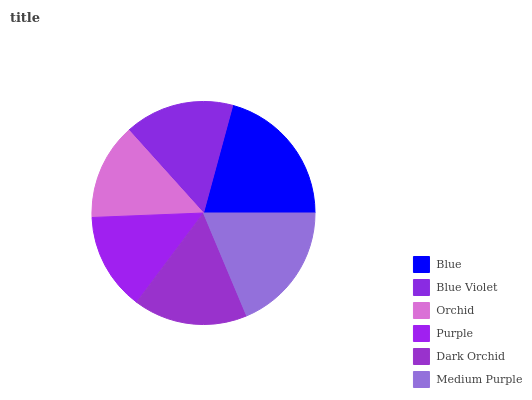Is Orchid the minimum?
Answer yes or no. Yes. Is Blue the maximum?
Answer yes or no. Yes. Is Blue Violet the minimum?
Answer yes or no. No. Is Blue Violet the maximum?
Answer yes or no. No. Is Blue greater than Blue Violet?
Answer yes or no. Yes. Is Blue Violet less than Blue?
Answer yes or no. Yes. Is Blue Violet greater than Blue?
Answer yes or no. No. Is Blue less than Blue Violet?
Answer yes or no. No. Is Dark Orchid the high median?
Answer yes or no. Yes. Is Blue Violet the low median?
Answer yes or no. Yes. Is Medium Purple the high median?
Answer yes or no. No. Is Orchid the low median?
Answer yes or no. No. 